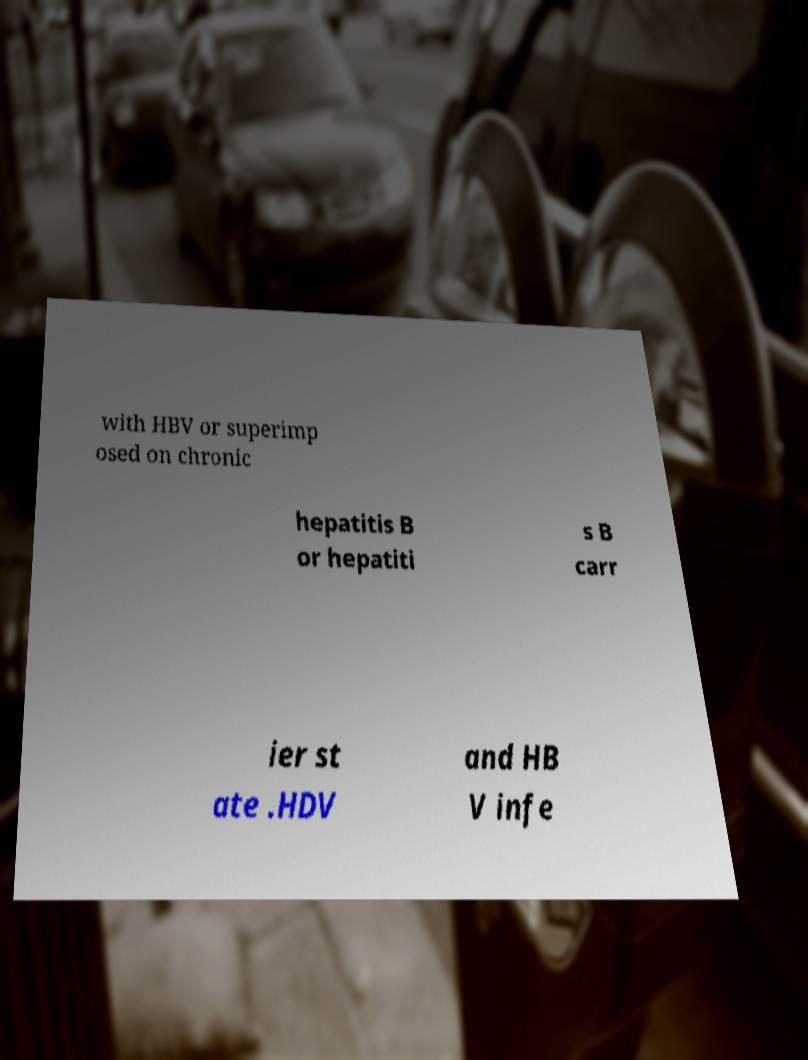Please identify and transcribe the text found in this image. with HBV or superimp osed on chronic hepatitis B or hepatiti s B carr ier st ate .HDV and HB V infe 